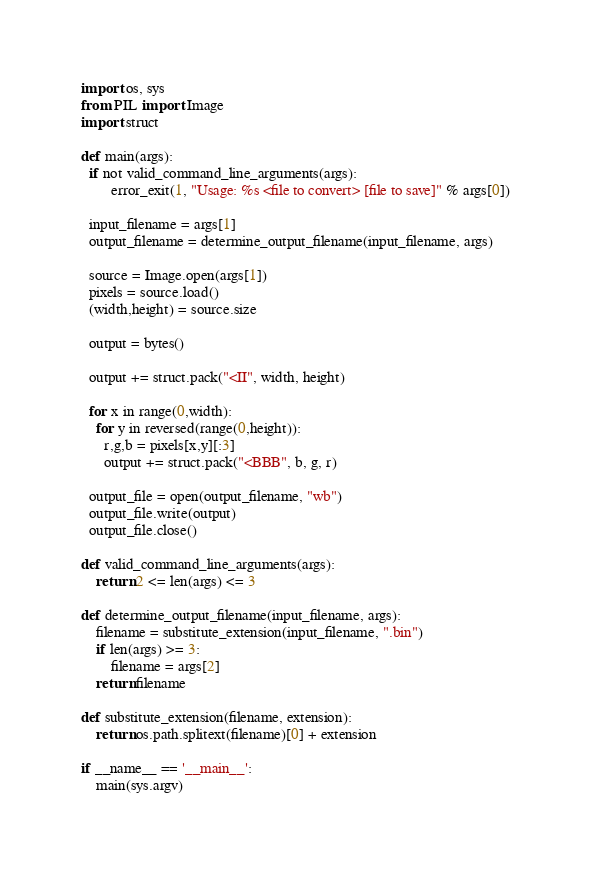Convert code to text. <code><loc_0><loc_0><loc_500><loc_500><_Python_>import os, sys
from PIL import Image
import struct

def main(args):
  if not valid_command_line_arguments(args):
        error_exit(1, "Usage: %s <file to convert> [file to save]" % args[0])

  input_filename = args[1]
  output_filename = determine_output_filename(input_filename, args)

  source = Image.open(args[1])
  pixels = source.load()
  (width,height) = source.size

  output = bytes()

  output += struct.pack("<II", width, height)

  for x in range(0,width):
    for y in reversed(range(0,height)):
      r,g,b = pixels[x,y][:3]
      output += struct.pack("<BBB", b, g, r)

  output_file = open(output_filename, "wb")
  output_file.write(output)
  output_file.close()

def valid_command_line_arguments(args):
    return 2 <= len(args) <= 3

def determine_output_filename(input_filename, args):
    filename = substitute_extension(input_filename, ".bin")
    if len(args) >= 3:
        filename = args[2]
    return filename

def substitute_extension(filename, extension):
    return os.path.splitext(filename)[0] + extension

if __name__ == '__main__':
    main(sys.argv)</code> 